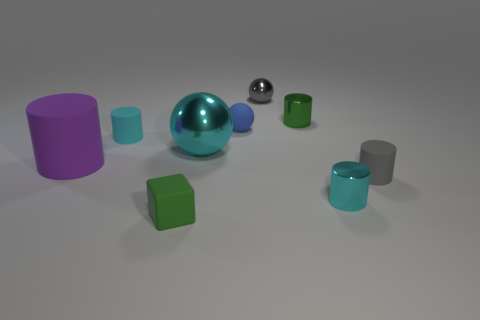Subtract all brown spheres. Subtract all yellow cylinders. How many spheres are left? 3 Add 1 big cyan metal balls. How many objects exist? 10 Subtract all cubes. How many objects are left? 8 Add 7 small green matte objects. How many small green matte objects are left? 8 Add 8 small spheres. How many small spheres exist? 10 Subtract 0 purple balls. How many objects are left? 9 Subtract all tiny green shiny things. Subtract all big shiny objects. How many objects are left? 7 